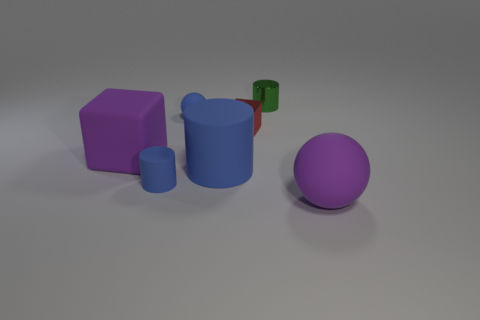How many cubes are the same material as the green cylinder?
Your response must be concise. 1. Is the number of large blue rubber things that are in front of the large matte ball the same as the number of big objects that are on the right side of the metal cube?
Your answer should be compact. No. There is a big blue rubber object; is it the same shape as the tiny object in front of the large blue matte object?
Your answer should be compact. Yes. What is the material of the large object that is the same color as the large ball?
Provide a succinct answer. Rubber. Is there anything else that is the same shape as the red object?
Provide a short and direct response. Yes. Are the large block and the small cylinder right of the red metallic thing made of the same material?
Provide a short and direct response. No. What color is the tiny matte object to the left of the sphere that is behind the small object in front of the rubber block?
Your response must be concise. Blue. Are there any other things that are the same size as the red cube?
Your answer should be compact. Yes. Is the color of the large matte sphere the same as the small thing in front of the big matte cylinder?
Provide a short and direct response. No. The tiny matte cylinder is what color?
Offer a terse response. Blue. 